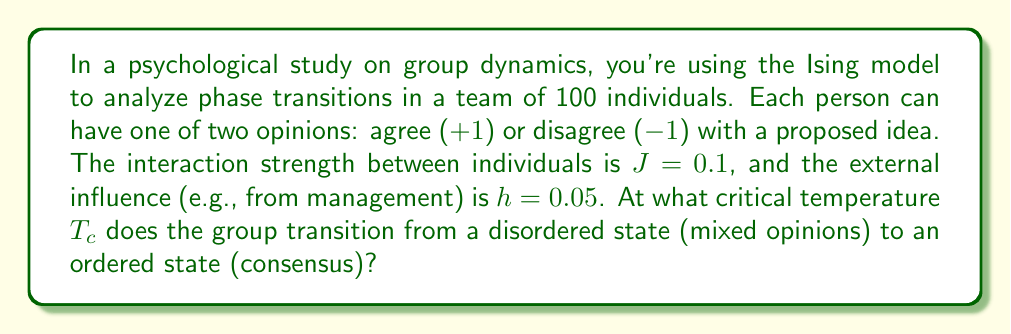Teach me how to tackle this problem. To solve this problem, we'll use the mean-field approximation of the Ising model:

1. The critical temperature in the mean-field Ising model is given by:

   $$T_c = zJ$$

   where $z$ is the coordination number (number of neighbors each site interacts with) and $J$ is the interaction strength.

2. In a fully connected network, which is often assumed in group dynamics, each individual interacts with all others. So, the coordination number is:

   $$z = N - 1 = 99$$

   where $N$ is the total number of individuals.

3. Substituting the values:

   $$T_c = (99)(0.1) = 9.9$$

4. Note that this result is in arbitrary units. In psychological contexts, we might interpret this as the "social temperature" or level of randomness in opinions required to break consensus.

5. The external field $h$ doesn't affect the critical temperature in the mean-field approximation, but it does influence the direction of consensus below $T_c$.

6. Below $T_c$, the group tends to align (reach consensus), while above $T_c$, opinions become more random and mixed.
Answer: $T_c = 9.9$ 